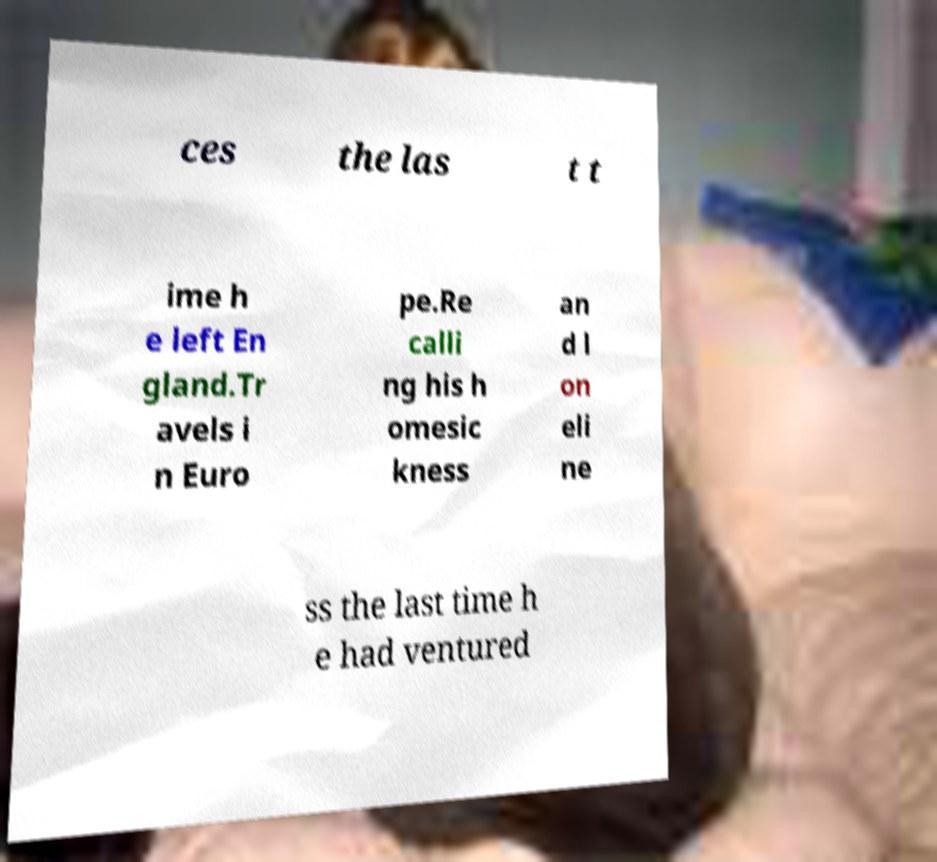I need the written content from this picture converted into text. Can you do that? ces the las t t ime h e left En gland.Tr avels i n Euro pe.Re calli ng his h omesic kness an d l on eli ne ss the last time h e had ventured 